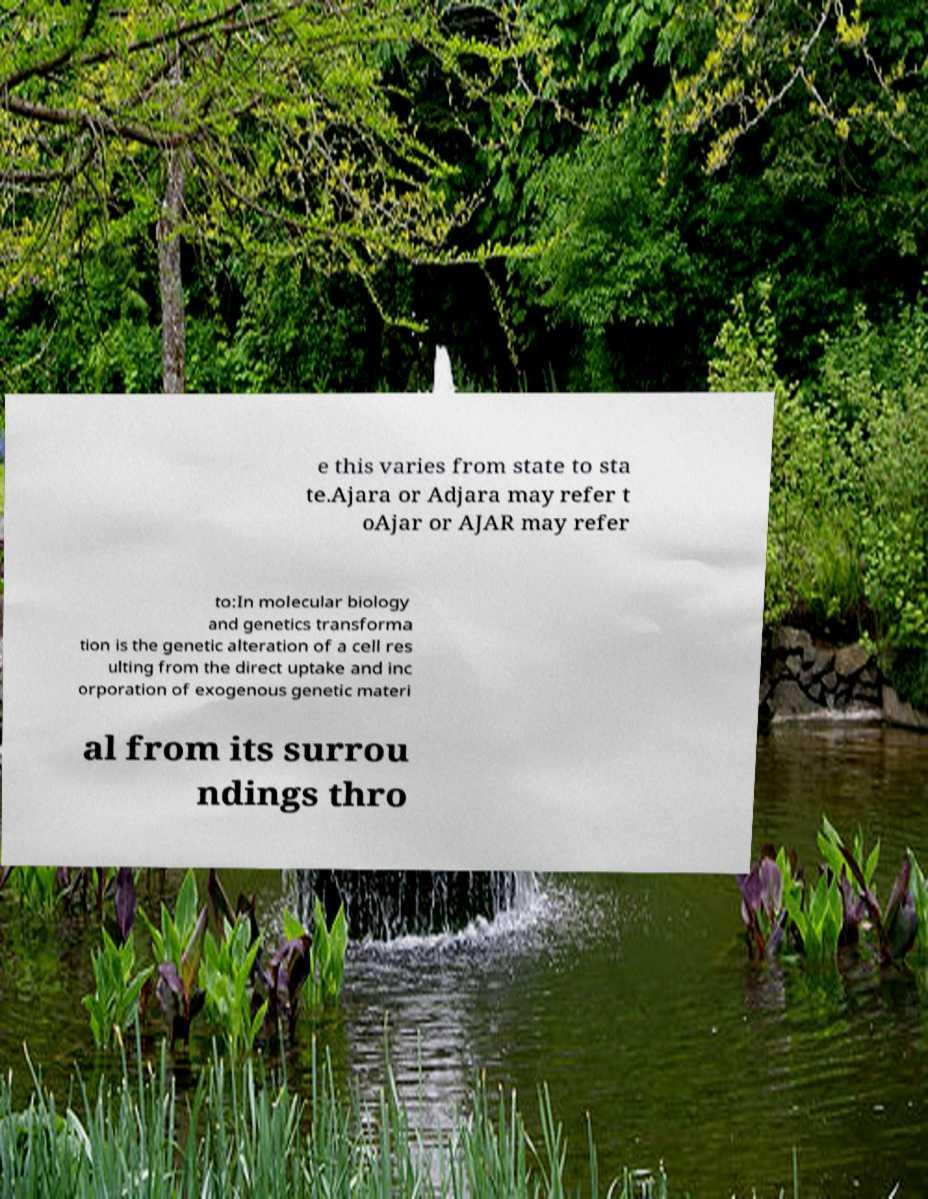Please read and relay the text visible in this image. What does it say? e this varies from state to sta te.Ajara or Adjara may refer t oAjar or AJAR may refer to:In molecular biology and genetics transforma tion is the genetic alteration of a cell res ulting from the direct uptake and inc orporation of exogenous genetic materi al from its surrou ndings thro 